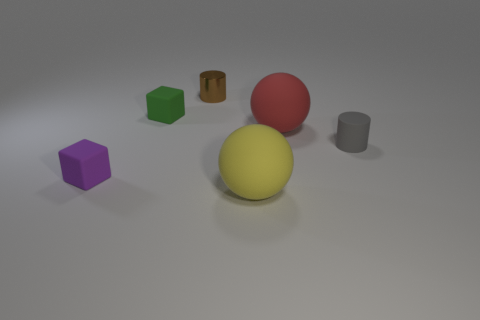Is there any other thing that has the same material as the small brown thing?
Provide a succinct answer. No. Does the metal object have the same size as the yellow rubber sphere that is on the right side of the green rubber cube?
Offer a terse response. No. How many things are small cylinders that are in front of the green thing or things that are in front of the gray rubber thing?
Your answer should be compact. 3. What is the color of the cylinder in front of the metal cylinder?
Offer a terse response. Gray. Are there any brown cylinders that are on the right side of the small thing in front of the tiny rubber cylinder?
Offer a terse response. Yes. Are there fewer small brown cylinders than large purple rubber spheres?
Ensure brevity in your answer.  No. What is the material of the small cube behind the small cylinder that is to the right of the brown metallic cylinder?
Offer a very short reply. Rubber. Do the brown thing and the gray thing have the same size?
Make the answer very short. Yes. What number of things are either yellow matte blocks or metal cylinders?
Provide a short and direct response. 1. What size is the object that is in front of the small gray matte object and on the right side of the small purple rubber object?
Keep it short and to the point. Large. 